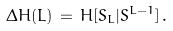<formula> <loc_0><loc_0><loc_500><loc_500>\Delta H ( L ) \, = \, H [ S _ { L } | S ^ { L - 1 } ] \, .</formula> 